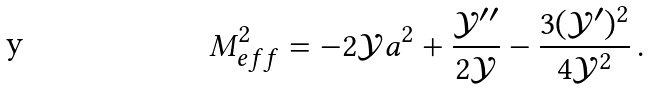<formula> <loc_0><loc_0><loc_500><loc_500>M ^ { 2 } _ { e f f } = - 2 \mathcal { Y } a ^ { 2 } + \frac { \mathcal { Y } ^ { \prime \prime } } { 2 \mathcal { Y } } - \frac { 3 ( \mathcal { Y } ^ { \prime } ) ^ { 2 } } { 4 \mathcal { Y } ^ { 2 } } \, .</formula> 